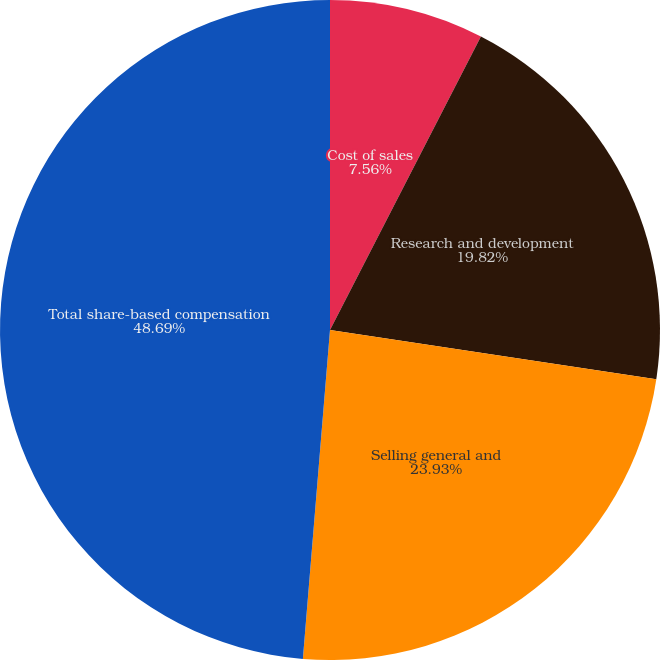<chart> <loc_0><loc_0><loc_500><loc_500><pie_chart><fcel>Cost of sales<fcel>Research and development<fcel>Selling general and<fcel>Total share-based compensation<nl><fcel>7.56%<fcel>19.82%<fcel>23.93%<fcel>48.69%<nl></chart> 